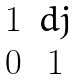Convert formula to latex. <formula><loc_0><loc_0><loc_500><loc_500>\begin{matrix} 1 & d j \\ 0 & 1 \end{matrix}</formula> 